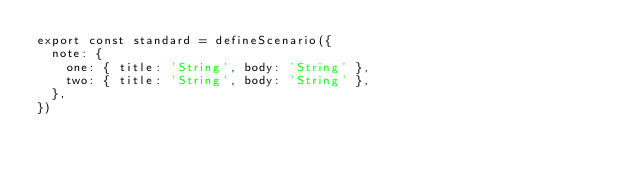<code> <loc_0><loc_0><loc_500><loc_500><_JavaScript_>export const standard = defineScenario({
  note: {
    one: { title: 'String', body: 'String' },
    two: { title: 'String', body: 'String' },
  },
})
</code> 